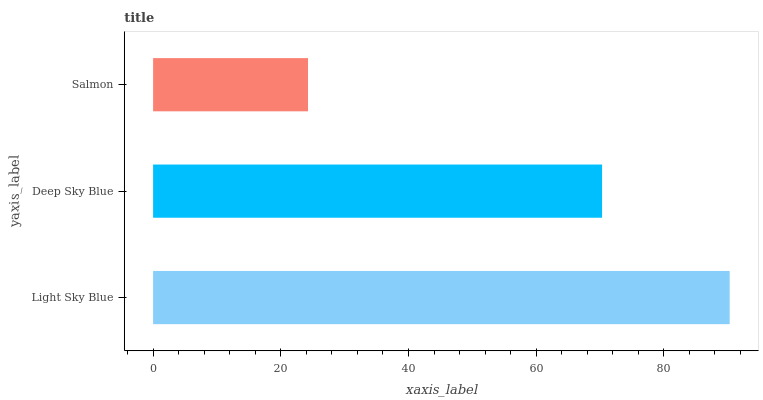Is Salmon the minimum?
Answer yes or no. Yes. Is Light Sky Blue the maximum?
Answer yes or no. Yes. Is Deep Sky Blue the minimum?
Answer yes or no. No. Is Deep Sky Blue the maximum?
Answer yes or no. No. Is Light Sky Blue greater than Deep Sky Blue?
Answer yes or no. Yes. Is Deep Sky Blue less than Light Sky Blue?
Answer yes or no. Yes. Is Deep Sky Blue greater than Light Sky Blue?
Answer yes or no. No. Is Light Sky Blue less than Deep Sky Blue?
Answer yes or no. No. Is Deep Sky Blue the high median?
Answer yes or no. Yes. Is Deep Sky Blue the low median?
Answer yes or no. Yes. Is Light Sky Blue the high median?
Answer yes or no. No. Is Salmon the low median?
Answer yes or no. No. 